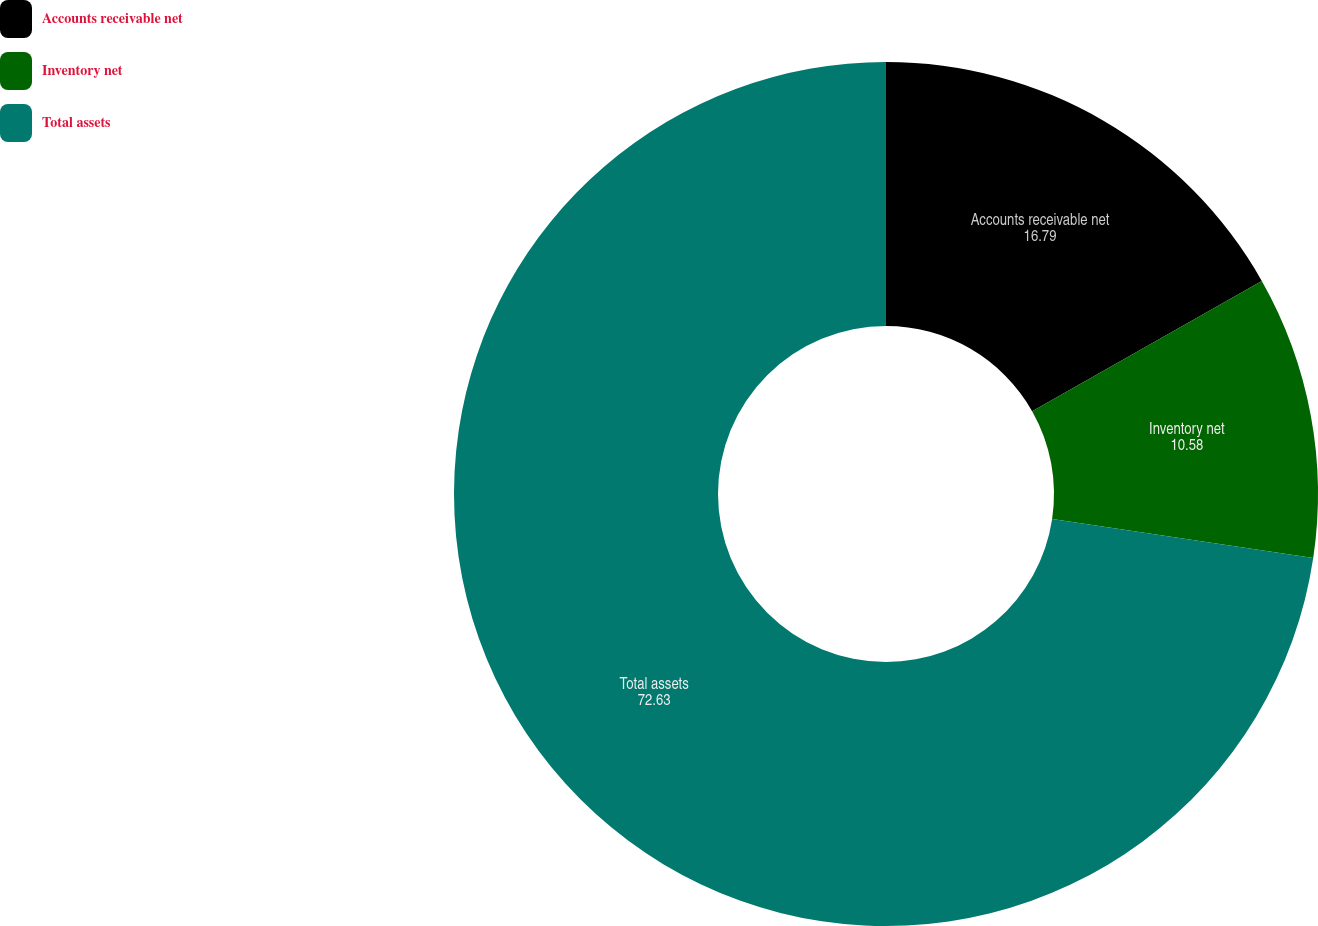Convert chart to OTSL. <chart><loc_0><loc_0><loc_500><loc_500><pie_chart><fcel>Accounts receivable net<fcel>Inventory net<fcel>Total assets<nl><fcel>16.79%<fcel>10.58%<fcel>72.63%<nl></chart> 